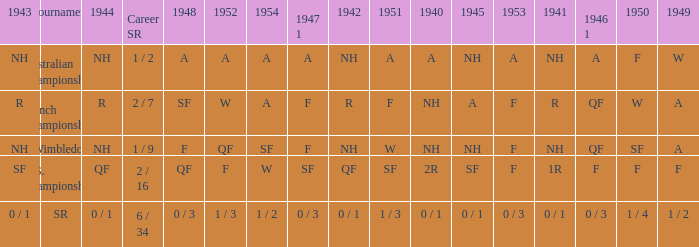What is the tournament that had a result of A in 1954 and NH in 1942? Australian Championships. 